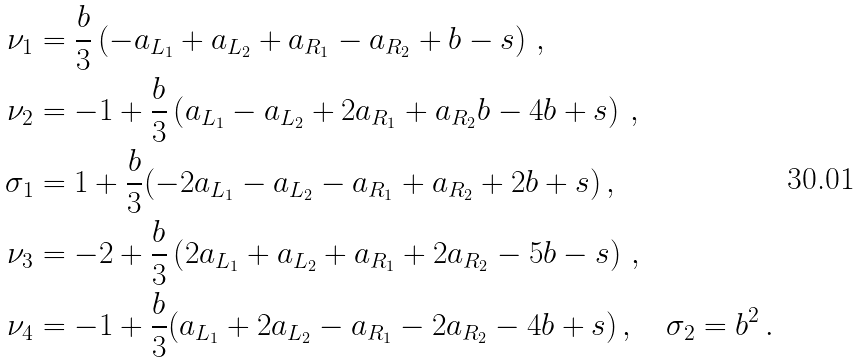<formula> <loc_0><loc_0><loc_500><loc_500>\nu _ { 1 } & = \frac { b } { 3 } \left ( - a _ { L _ { 1 } } + a _ { L _ { 2 } } + a _ { R _ { 1 } } - a _ { R _ { 2 } } + b - s \right ) \, , \\ \nu _ { 2 } & = - 1 + \frac { b } { 3 } \left ( a _ { L _ { 1 } } - a _ { L _ { 2 } } + 2 a _ { R _ { 1 } } + a _ { R _ { 2 } } b - 4 b + s \right ) \, , \\ \sigma _ { 1 } & = 1 + \frac { b } { 3 } ( - 2 a _ { L _ { 1 } } - a _ { L _ { 2 } } - a _ { R _ { 1 } } + a _ { R _ { 2 } } + 2 b + s ) \, , \\ \nu _ { 3 } & = - 2 + \frac { b } { 3 } \left ( 2 a _ { L _ { 1 } } + a _ { L _ { 2 } } + a _ { R _ { 1 } } + 2 a _ { R _ { 2 } } - 5 b - s \right ) \, , \\ \nu _ { 4 } & = - 1 + \frac { b } { 3 } ( a _ { L _ { 1 } } + 2 a _ { L _ { 2 } } - a _ { R _ { 1 } } - 2 a _ { R _ { 2 } } - 4 b + s ) \, , \quad \sigma _ { 2 } = b ^ { 2 } \, .</formula> 